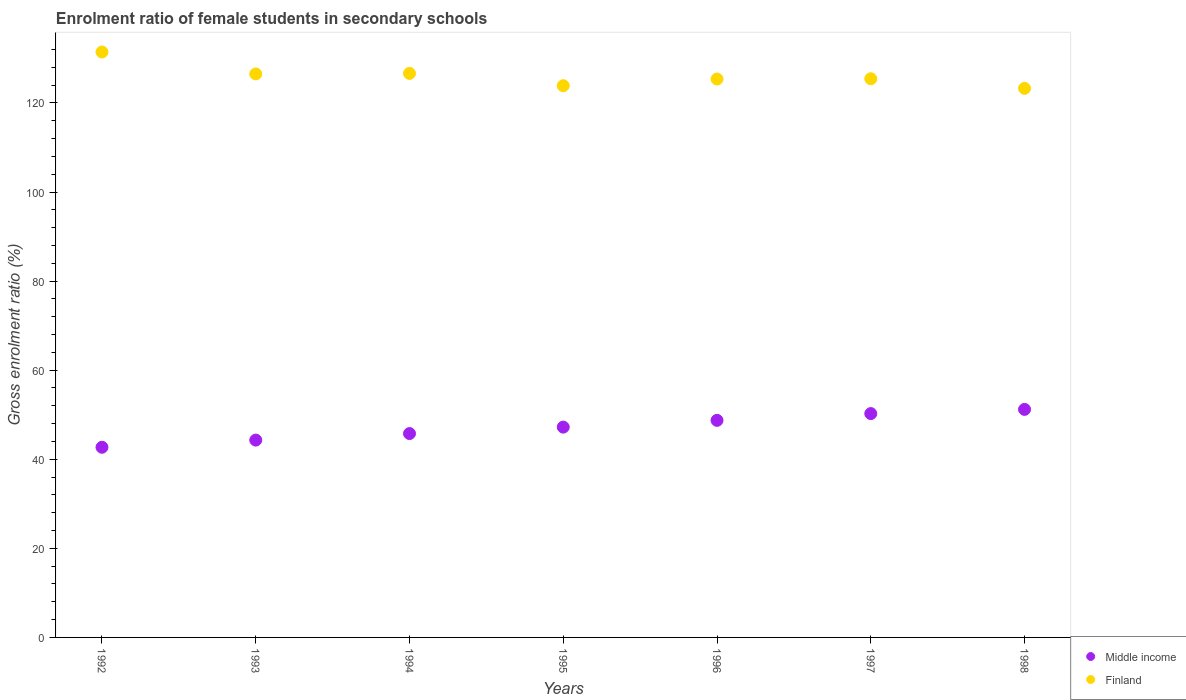Is the number of dotlines equal to the number of legend labels?
Offer a terse response. Yes. What is the enrolment ratio of female students in secondary schools in Middle income in 1993?
Offer a terse response. 44.3. Across all years, what is the maximum enrolment ratio of female students in secondary schools in Middle income?
Your answer should be compact. 51.2. Across all years, what is the minimum enrolment ratio of female students in secondary schools in Finland?
Make the answer very short. 123.27. What is the total enrolment ratio of female students in secondary schools in Middle income in the graph?
Provide a short and direct response. 330.17. What is the difference between the enrolment ratio of female students in secondary schools in Finland in 1993 and that in 1997?
Keep it short and to the point. 1.08. What is the difference between the enrolment ratio of female students in secondary schools in Finland in 1997 and the enrolment ratio of female students in secondary schools in Middle income in 1996?
Your answer should be very brief. 76.7. What is the average enrolment ratio of female students in secondary schools in Middle income per year?
Give a very brief answer. 47.17. In the year 1993, what is the difference between the enrolment ratio of female students in secondary schools in Middle income and enrolment ratio of female students in secondary schools in Finland?
Provide a succinct answer. -82.21. In how many years, is the enrolment ratio of female students in secondary schools in Finland greater than 44 %?
Provide a short and direct response. 7. What is the ratio of the enrolment ratio of female students in secondary schools in Finland in 1992 to that in 1997?
Keep it short and to the point. 1.05. Is the difference between the enrolment ratio of female students in secondary schools in Middle income in 1993 and 1994 greater than the difference between the enrolment ratio of female students in secondary schools in Finland in 1993 and 1994?
Provide a short and direct response. No. What is the difference between the highest and the second highest enrolment ratio of female students in secondary schools in Middle income?
Your response must be concise. 0.94. What is the difference between the highest and the lowest enrolment ratio of female students in secondary schools in Finland?
Your answer should be compact. 8.16. Is the sum of the enrolment ratio of female students in secondary schools in Middle income in 1997 and 1998 greater than the maximum enrolment ratio of female students in secondary schools in Finland across all years?
Keep it short and to the point. No. Does the enrolment ratio of female students in secondary schools in Middle income monotonically increase over the years?
Provide a short and direct response. Yes. Is the enrolment ratio of female students in secondary schools in Finland strictly less than the enrolment ratio of female students in secondary schools in Middle income over the years?
Offer a terse response. No. What is the difference between two consecutive major ticks on the Y-axis?
Keep it short and to the point. 20. Does the graph contain grids?
Keep it short and to the point. No. How many legend labels are there?
Offer a very short reply. 2. How are the legend labels stacked?
Offer a very short reply. Vertical. What is the title of the graph?
Your answer should be compact. Enrolment ratio of female students in secondary schools. Does "Marshall Islands" appear as one of the legend labels in the graph?
Provide a succinct answer. No. What is the label or title of the Y-axis?
Your answer should be compact. Gross enrolment ratio (%). What is the Gross enrolment ratio (%) of Middle income in 1992?
Your answer should be very brief. 42.69. What is the Gross enrolment ratio (%) in Finland in 1992?
Provide a succinct answer. 131.43. What is the Gross enrolment ratio (%) in Middle income in 1993?
Keep it short and to the point. 44.3. What is the Gross enrolment ratio (%) of Finland in 1993?
Provide a short and direct response. 126.52. What is the Gross enrolment ratio (%) in Middle income in 1994?
Your answer should be very brief. 45.77. What is the Gross enrolment ratio (%) in Finland in 1994?
Offer a very short reply. 126.63. What is the Gross enrolment ratio (%) in Middle income in 1995?
Offer a terse response. 47.22. What is the Gross enrolment ratio (%) in Finland in 1995?
Make the answer very short. 123.87. What is the Gross enrolment ratio (%) in Middle income in 1996?
Provide a succinct answer. 48.74. What is the Gross enrolment ratio (%) in Finland in 1996?
Make the answer very short. 125.37. What is the Gross enrolment ratio (%) in Middle income in 1997?
Your response must be concise. 50.25. What is the Gross enrolment ratio (%) in Finland in 1997?
Provide a short and direct response. 125.43. What is the Gross enrolment ratio (%) in Middle income in 1998?
Your answer should be compact. 51.2. What is the Gross enrolment ratio (%) in Finland in 1998?
Your answer should be very brief. 123.27. Across all years, what is the maximum Gross enrolment ratio (%) of Middle income?
Keep it short and to the point. 51.2. Across all years, what is the maximum Gross enrolment ratio (%) in Finland?
Your answer should be very brief. 131.43. Across all years, what is the minimum Gross enrolment ratio (%) in Middle income?
Make the answer very short. 42.69. Across all years, what is the minimum Gross enrolment ratio (%) in Finland?
Make the answer very short. 123.27. What is the total Gross enrolment ratio (%) in Middle income in the graph?
Your response must be concise. 330.17. What is the total Gross enrolment ratio (%) of Finland in the graph?
Offer a terse response. 882.52. What is the difference between the Gross enrolment ratio (%) in Middle income in 1992 and that in 1993?
Your answer should be compact. -1.61. What is the difference between the Gross enrolment ratio (%) in Finland in 1992 and that in 1993?
Keep it short and to the point. 4.92. What is the difference between the Gross enrolment ratio (%) in Middle income in 1992 and that in 1994?
Make the answer very short. -3.08. What is the difference between the Gross enrolment ratio (%) in Finland in 1992 and that in 1994?
Your answer should be very brief. 4.8. What is the difference between the Gross enrolment ratio (%) of Middle income in 1992 and that in 1995?
Keep it short and to the point. -4.52. What is the difference between the Gross enrolment ratio (%) in Finland in 1992 and that in 1995?
Ensure brevity in your answer.  7.56. What is the difference between the Gross enrolment ratio (%) of Middle income in 1992 and that in 1996?
Provide a short and direct response. -6.04. What is the difference between the Gross enrolment ratio (%) of Finland in 1992 and that in 1996?
Provide a short and direct response. 6.07. What is the difference between the Gross enrolment ratio (%) of Middle income in 1992 and that in 1997?
Make the answer very short. -7.56. What is the difference between the Gross enrolment ratio (%) of Finland in 1992 and that in 1997?
Provide a succinct answer. 6. What is the difference between the Gross enrolment ratio (%) in Middle income in 1992 and that in 1998?
Provide a succinct answer. -8.5. What is the difference between the Gross enrolment ratio (%) in Finland in 1992 and that in 1998?
Your answer should be very brief. 8.16. What is the difference between the Gross enrolment ratio (%) in Middle income in 1993 and that in 1994?
Provide a short and direct response. -1.47. What is the difference between the Gross enrolment ratio (%) in Finland in 1993 and that in 1994?
Keep it short and to the point. -0.12. What is the difference between the Gross enrolment ratio (%) in Middle income in 1993 and that in 1995?
Give a very brief answer. -2.91. What is the difference between the Gross enrolment ratio (%) in Finland in 1993 and that in 1995?
Make the answer very short. 2.65. What is the difference between the Gross enrolment ratio (%) of Middle income in 1993 and that in 1996?
Provide a succinct answer. -4.43. What is the difference between the Gross enrolment ratio (%) in Finland in 1993 and that in 1996?
Offer a terse response. 1.15. What is the difference between the Gross enrolment ratio (%) in Middle income in 1993 and that in 1997?
Offer a very short reply. -5.95. What is the difference between the Gross enrolment ratio (%) of Finland in 1993 and that in 1997?
Make the answer very short. 1.08. What is the difference between the Gross enrolment ratio (%) in Middle income in 1993 and that in 1998?
Keep it short and to the point. -6.89. What is the difference between the Gross enrolment ratio (%) in Finland in 1993 and that in 1998?
Offer a terse response. 3.24. What is the difference between the Gross enrolment ratio (%) of Middle income in 1994 and that in 1995?
Provide a short and direct response. -1.44. What is the difference between the Gross enrolment ratio (%) in Finland in 1994 and that in 1995?
Provide a succinct answer. 2.77. What is the difference between the Gross enrolment ratio (%) in Middle income in 1994 and that in 1996?
Your answer should be compact. -2.96. What is the difference between the Gross enrolment ratio (%) in Finland in 1994 and that in 1996?
Ensure brevity in your answer.  1.27. What is the difference between the Gross enrolment ratio (%) in Middle income in 1994 and that in 1997?
Ensure brevity in your answer.  -4.48. What is the difference between the Gross enrolment ratio (%) of Finland in 1994 and that in 1997?
Keep it short and to the point. 1.2. What is the difference between the Gross enrolment ratio (%) in Middle income in 1994 and that in 1998?
Your answer should be very brief. -5.42. What is the difference between the Gross enrolment ratio (%) in Finland in 1994 and that in 1998?
Your response must be concise. 3.36. What is the difference between the Gross enrolment ratio (%) of Middle income in 1995 and that in 1996?
Your response must be concise. -1.52. What is the difference between the Gross enrolment ratio (%) of Finland in 1995 and that in 1996?
Make the answer very short. -1.5. What is the difference between the Gross enrolment ratio (%) in Middle income in 1995 and that in 1997?
Offer a very short reply. -3.04. What is the difference between the Gross enrolment ratio (%) of Finland in 1995 and that in 1997?
Keep it short and to the point. -1.56. What is the difference between the Gross enrolment ratio (%) of Middle income in 1995 and that in 1998?
Give a very brief answer. -3.98. What is the difference between the Gross enrolment ratio (%) in Finland in 1995 and that in 1998?
Provide a short and direct response. 0.6. What is the difference between the Gross enrolment ratio (%) in Middle income in 1996 and that in 1997?
Your answer should be very brief. -1.52. What is the difference between the Gross enrolment ratio (%) of Finland in 1996 and that in 1997?
Offer a terse response. -0.07. What is the difference between the Gross enrolment ratio (%) in Middle income in 1996 and that in 1998?
Offer a terse response. -2.46. What is the difference between the Gross enrolment ratio (%) of Finland in 1996 and that in 1998?
Your response must be concise. 2.09. What is the difference between the Gross enrolment ratio (%) of Middle income in 1997 and that in 1998?
Provide a short and direct response. -0.94. What is the difference between the Gross enrolment ratio (%) in Finland in 1997 and that in 1998?
Provide a succinct answer. 2.16. What is the difference between the Gross enrolment ratio (%) in Middle income in 1992 and the Gross enrolment ratio (%) in Finland in 1993?
Make the answer very short. -83.82. What is the difference between the Gross enrolment ratio (%) in Middle income in 1992 and the Gross enrolment ratio (%) in Finland in 1994?
Offer a very short reply. -83.94. What is the difference between the Gross enrolment ratio (%) in Middle income in 1992 and the Gross enrolment ratio (%) in Finland in 1995?
Your answer should be compact. -81.17. What is the difference between the Gross enrolment ratio (%) of Middle income in 1992 and the Gross enrolment ratio (%) of Finland in 1996?
Provide a succinct answer. -82.67. What is the difference between the Gross enrolment ratio (%) of Middle income in 1992 and the Gross enrolment ratio (%) of Finland in 1997?
Your answer should be very brief. -82.74. What is the difference between the Gross enrolment ratio (%) of Middle income in 1992 and the Gross enrolment ratio (%) of Finland in 1998?
Provide a succinct answer. -80.58. What is the difference between the Gross enrolment ratio (%) of Middle income in 1993 and the Gross enrolment ratio (%) of Finland in 1994?
Make the answer very short. -82.33. What is the difference between the Gross enrolment ratio (%) of Middle income in 1993 and the Gross enrolment ratio (%) of Finland in 1995?
Offer a terse response. -79.57. What is the difference between the Gross enrolment ratio (%) of Middle income in 1993 and the Gross enrolment ratio (%) of Finland in 1996?
Give a very brief answer. -81.06. What is the difference between the Gross enrolment ratio (%) in Middle income in 1993 and the Gross enrolment ratio (%) in Finland in 1997?
Your response must be concise. -81.13. What is the difference between the Gross enrolment ratio (%) in Middle income in 1993 and the Gross enrolment ratio (%) in Finland in 1998?
Your response must be concise. -78.97. What is the difference between the Gross enrolment ratio (%) in Middle income in 1994 and the Gross enrolment ratio (%) in Finland in 1995?
Make the answer very short. -78.1. What is the difference between the Gross enrolment ratio (%) of Middle income in 1994 and the Gross enrolment ratio (%) of Finland in 1996?
Make the answer very short. -79.59. What is the difference between the Gross enrolment ratio (%) in Middle income in 1994 and the Gross enrolment ratio (%) in Finland in 1997?
Make the answer very short. -79.66. What is the difference between the Gross enrolment ratio (%) in Middle income in 1994 and the Gross enrolment ratio (%) in Finland in 1998?
Your response must be concise. -77.5. What is the difference between the Gross enrolment ratio (%) in Middle income in 1995 and the Gross enrolment ratio (%) in Finland in 1996?
Provide a succinct answer. -78.15. What is the difference between the Gross enrolment ratio (%) in Middle income in 1995 and the Gross enrolment ratio (%) in Finland in 1997?
Your answer should be very brief. -78.22. What is the difference between the Gross enrolment ratio (%) in Middle income in 1995 and the Gross enrolment ratio (%) in Finland in 1998?
Make the answer very short. -76.06. What is the difference between the Gross enrolment ratio (%) in Middle income in 1996 and the Gross enrolment ratio (%) in Finland in 1997?
Your answer should be compact. -76.7. What is the difference between the Gross enrolment ratio (%) of Middle income in 1996 and the Gross enrolment ratio (%) of Finland in 1998?
Make the answer very short. -74.54. What is the difference between the Gross enrolment ratio (%) in Middle income in 1997 and the Gross enrolment ratio (%) in Finland in 1998?
Make the answer very short. -73.02. What is the average Gross enrolment ratio (%) in Middle income per year?
Give a very brief answer. 47.17. What is the average Gross enrolment ratio (%) of Finland per year?
Your answer should be very brief. 126.07. In the year 1992, what is the difference between the Gross enrolment ratio (%) in Middle income and Gross enrolment ratio (%) in Finland?
Offer a terse response. -88.74. In the year 1993, what is the difference between the Gross enrolment ratio (%) in Middle income and Gross enrolment ratio (%) in Finland?
Provide a succinct answer. -82.21. In the year 1994, what is the difference between the Gross enrolment ratio (%) of Middle income and Gross enrolment ratio (%) of Finland?
Offer a very short reply. -80.86. In the year 1995, what is the difference between the Gross enrolment ratio (%) in Middle income and Gross enrolment ratio (%) in Finland?
Keep it short and to the point. -76.65. In the year 1996, what is the difference between the Gross enrolment ratio (%) of Middle income and Gross enrolment ratio (%) of Finland?
Your answer should be compact. -76.63. In the year 1997, what is the difference between the Gross enrolment ratio (%) in Middle income and Gross enrolment ratio (%) in Finland?
Offer a very short reply. -75.18. In the year 1998, what is the difference between the Gross enrolment ratio (%) of Middle income and Gross enrolment ratio (%) of Finland?
Your answer should be very brief. -72.08. What is the ratio of the Gross enrolment ratio (%) of Middle income in 1992 to that in 1993?
Offer a terse response. 0.96. What is the ratio of the Gross enrolment ratio (%) in Finland in 1992 to that in 1993?
Ensure brevity in your answer.  1.04. What is the ratio of the Gross enrolment ratio (%) of Middle income in 1992 to that in 1994?
Keep it short and to the point. 0.93. What is the ratio of the Gross enrolment ratio (%) of Finland in 1992 to that in 1994?
Your response must be concise. 1.04. What is the ratio of the Gross enrolment ratio (%) of Middle income in 1992 to that in 1995?
Your response must be concise. 0.9. What is the ratio of the Gross enrolment ratio (%) of Finland in 1992 to that in 1995?
Give a very brief answer. 1.06. What is the ratio of the Gross enrolment ratio (%) of Middle income in 1992 to that in 1996?
Offer a terse response. 0.88. What is the ratio of the Gross enrolment ratio (%) of Finland in 1992 to that in 1996?
Provide a succinct answer. 1.05. What is the ratio of the Gross enrolment ratio (%) in Middle income in 1992 to that in 1997?
Your response must be concise. 0.85. What is the ratio of the Gross enrolment ratio (%) of Finland in 1992 to that in 1997?
Your answer should be very brief. 1.05. What is the ratio of the Gross enrolment ratio (%) in Middle income in 1992 to that in 1998?
Offer a very short reply. 0.83. What is the ratio of the Gross enrolment ratio (%) of Finland in 1992 to that in 1998?
Your answer should be very brief. 1.07. What is the ratio of the Gross enrolment ratio (%) in Middle income in 1993 to that in 1994?
Your answer should be compact. 0.97. What is the ratio of the Gross enrolment ratio (%) in Finland in 1993 to that in 1994?
Keep it short and to the point. 1. What is the ratio of the Gross enrolment ratio (%) in Middle income in 1993 to that in 1995?
Keep it short and to the point. 0.94. What is the ratio of the Gross enrolment ratio (%) in Finland in 1993 to that in 1995?
Your answer should be very brief. 1.02. What is the ratio of the Gross enrolment ratio (%) in Middle income in 1993 to that in 1996?
Keep it short and to the point. 0.91. What is the ratio of the Gross enrolment ratio (%) in Finland in 1993 to that in 1996?
Provide a short and direct response. 1.01. What is the ratio of the Gross enrolment ratio (%) in Middle income in 1993 to that in 1997?
Make the answer very short. 0.88. What is the ratio of the Gross enrolment ratio (%) of Finland in 1993 to that in 1997?
Offer a terse response. 1.01. What is the ratio of the Gross enrolment ratio (%) of Middle income in 1993 to that in 1998?
Your answer should be compact. 0.87. What is the ratio of the Gross enrolment ratio (%) in Finland in 1993 to that in 1998?
Provide a succinct answer. 1.03. What is the ratio of the Gross enrolment ratio (%) of Middle income in 1994 to that in 1995?
Provide a short and direct response. 0.97. What is the ratio of the Gross enrolment ratio (%) in Finland in 1994 to that in 1995?
Offer a terse response. 1.02. What is the ratio of the Gross enrolment ratio (%) in Middle income in 1994 to that in 1996?
Offer a terse response. 0.94. What is the ratio of the Gross enrolment ratio (%) of Middle income in 1994 to that in 1997?
Your answer should be very brief. 0.91. What is the ratio of the Gross enrolment ratio (%) in Finland in 1994 to that in 1997?
Ensure brevity in your answer.  1.01. What is the ratio of the Gross enrolment ratio (%) of Middle income in 1994 to that in 1998?
Give a very brief answer. 0.89. What is the ratio of the Gross enrolment ratio (%) of Finland in 1994 to that in 1998?
Offer a terse response. 1.03. What is the ratio of the Gross enrolment ratio (%) in Middle income in 1995 to that in 1996?
Offer a very short reply. 0.97. What is the ratio of the Gross enrolment ratio (%) in Middle income in 1995 to that in 1997?
Your response must be concise. 0.94. What is the ratio of the Gross enrolment ratio (%) of Finland in 1995 to that in 1997?
Ensure brevity in your answer.  0.99. What is the ratio of the Gross enrolment ratio (%) of Middle income in 1995 to that in 1998?
Provide a short and direct response. 0.92. What is the ratio of the Gross enrolment ratio (%) in Middle income in 1996 to that in 1997?
Your answer should be very brief. 0.97. What is the ratio of the Gross enrolment ratio (%) in Finland in 1996 to that in 1997?
Your answer should be very brief. 1. What is the ratio of the Gross enrolment ratio (%) in Middle income in 1996 to that in 1998?
Give a very brief answer. 0.95. What is the ratio of the Gross enrolment ratio (%) of Middle income in 1997 to that in 1998?
Your answer should be compact. 0.98. What is the ratio of the Gross enrolment ratio (%) in Finland in 1997 to that in 1998?
Your response must be concise. 1.02. What is the difference between the highest and the second highest Gross enrolment ratio (%) of Middle income?
Offer a terse response. 0.94. What is the difference between the highest and the second highest Gross enrolment ratio (%) of Finland?
Keep it short and to the point. 4.8. What is the difference between the highest and the lowest Gross enrolment ratio (%) in Middle income?
Provide a short and direct response. 8.5. What is the difference between the highest and the lowest Gross enrolment ratio (%) in Finland?
Give a very brief answer. 8.16. 